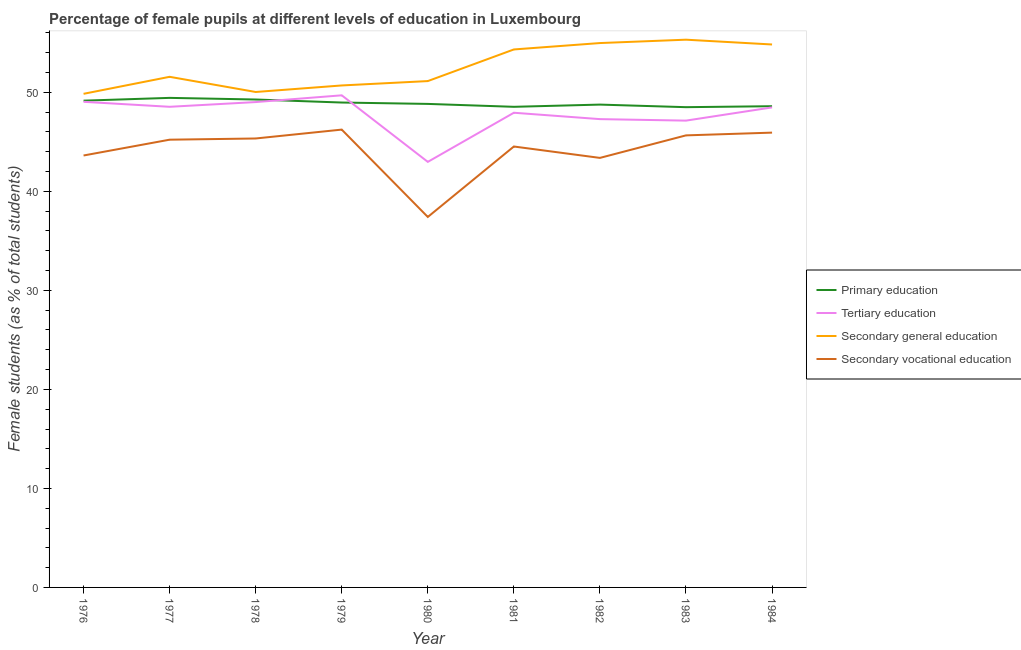Is the number of lines equal to the number of legend labels?
Offer a very short reply. Yes. What is the percentage of female students in tertiary education in 1981?
Offer a very short reply. 47.94. Across all years, what is the maximum percentage of female students in tertiary education?
Ensure brevity in your answer.  49.7. Across all years, what is the minimum percentage of female students in secondary education?
Your answer should be very brief. 49.85. In which year was the percentage of female students in primary education maximum?
Offer a very short reply. 1977. In which year was the percentage of female students in primary education minimum?
Provide a succinct answer. 1983. What is the total percentage of female students in primary education in the graph?
Provide a succinct answer. 440.09. What is the difference between the percentage of female students in tertiary education in 1977 and that in 1983?
Your answer should be very brief. 1.4. What is the difference between the percentage of female students in secondary education in 1978 and the percentage of female students in secondary vocational education in 1979?
Your answer should be compact. 3.8. What is the average percentage of female students in primary education per year?
Make the answer very short. 48.9. In the year 1978, what is the difference between the percentage of female students in tertiary education and percentage of female students in secondary vocational education?
Offer a terse response. 3.68. What is the ratio of the percentage of female students in tertiary education in 1976 to that in 1980?
Make the answer very short. 1.14. What is the difference between the highest and the second highest percentage of female students in tertiary education?
Offer a terse response. 0.66. What is the difference between the highest and the lowest percentage of female students in secondary vocational education?
Your response must be concise. 8.82. In how many years, is the percentage of female students in secondary vocational education greater than the average percentage of female students in secondary vocational education taken over all years?
Provide a short and direct response. 6. Is the sum of the percentage of female students in secondary education in 1980 and 1982 greater than the maximum percentage of female students in tertiary education across all years?
Your response must be concise. Yes. Is it the case that in every year, the sum of the percentage of female students in primary education and percentage of female students in tertiary education is greater than the percentage of female students in secondary education?
Your response must be concise. Yes. Does the percentage of female students in secondary education monotonically increase over the years?
Ensure brevity in your answer.  No. Is the percentage of female students in secondary education strictly greater than the percentage of female students in tertiary education over the years?
Provide a succinct answer. Yes. Is the percentage of female students in secondary education strictly less than the percentage of female students in tertiary education over the years?
Provide a succinct answer. No. How many lines are there?
Ensure brevity in your answer.  4. How many years are there in the graph?
Provide a short and direct response. 9. Are the values on the major ticks of Y-axis written in scientific E-notation?
Ensure brevity in your answer.  No. Where does the legend appear in the graph?
Offer a very short reply. Center right. What is the title of the graph?
Offer a terse response. Percentage of female pupils at different levels of education in Luxembourg. Does "UNAIDS" appear as one of the legend labels in the graph?
Give a very brief answer. No. What is the label or title of the Y-axis?
Keep it short and to the point. Female students (as % of total students). What is the Female students (as % of total students) in Primary education in 1976?
Offer a terse response. 49.16. What is the Female students (as % of total students) of Tertiary education in 1976?
Give a very brief answer. 49.04. What is the Female students (as % of total students) in Secondary general education in 1976?
Your answer should be compact. 49.85. What is the Female students (as % of total students) of Secondary vocational education in 1976?
Give a very brief answer. 43.62. What is the Female students (as % of total students) of Primary education in 1977?
Give a very brief answer. 49.44. What is the Female students (as % of total students) in Tertiary education in 1977?
Your answer should be very brief. 48.54. What is the Female students (as % of total students) in Secondary general education in 1977?
Your response must be concise. 51.57. What is the Female students (as % of total students) of Secondary vocational education in 1977?
Your response must be concise. 45.22. What is the Female students (as % of total students) in Primary education in 1978?
Your response must be concise. 49.28. What is the Female students (as % of total students) in Tertiary education in 1978?
Offer a terse response. 49.02. What is the Female students (as % of total students) in Secondary general education in 1978?
Your response must be concise. 50.04. What is the Female students (as % of total students) of Secondary vocational education in 1978?
Your answer should be very brief. 45.34. What is the Female students (as % of total students) of Primary education in 1979?
Give a very brief answer. 48.97. What is the Female students (as % of total students) of Tertiary education in 1979?
Your response must be concise. 49.7. What is the Female students (as % of total students) in Secondary general education in 1979?
Make the answer very short. 50.7. What is the Female students (as % of total students) of Secondary vocational education in 1979?
Provide a succinct answer. 46.24. What is the Female students (as % of total students) in Primary education in 1980?
Your response must be concise. 48.83. What is the Female students (as % of total students) in Tertiary education in 1980?
Provide a short and direct response. 42.98. What is the Female students (as % of total students) of Secondary general education in 1980?
Offer a very short reply. 51.14. What is the Female students (as % of total students) of Secondary vocational education in 1980?
Offer a very short reply. 37.41. What is the Female students (as % of total students) in Primary education in 1981?
Offer a terse response. 48.54. What is the Female students (as % of total students) in Tertiary education in 1981?
Provide a succinct answer. 47.94. What is the Female students (as % of total students) in Secondary general education in 1981?
Provide a succinct answer. 54.33. What is the Female students (as % of total students) in Secondary vocational education in 1981?
Your answer should be very brief. 44.53. What is the Female students (as % of total students) in Primary education in 1982?
Provide a short and direct response. 48.76. What is the Female students (as % of total students) of Tertiary education in 1982?
Your answer should be very brief. 47.3. What is the Female students (as % of total students) of Secondary general education in 1982?
Make the answer very short. 54.98. What is the Female students (as % of total students) in Secondary vocational education in 1982?
Ensure brevity in your answer.  43.38. What is the Female students (as % of total students) in Primary education in 1983?
Your answer should be very brief. 48.5. What is the Female students (as % of total students) in Tertiary education in 1983?
Keep it short and to the point. 47.14. What is the Female students (as % of total students) of Secondary general education in 1983?
Your response must be concise. 55.32. What is the Female students (as % of total students) of Secondary vocational education in 1983?
Ensure brevity in your answer.  45.65. What is the Female students (as % of total students) in Primary education in 1984?
Offer a very short reply. 48.6. What is the Female students (as % of total students) of Tertiary education in 1984?
Offer a terse response. 48.48. What is the Female students (as % of total students) of Secondary general education in 1984?
Keep it short and to the point. 54.83. What is the Female students (as % of total students) of Secondary vocational education in 1984?
Offer a very short reply. 45.93. Across all years, what is the maximum Female students (as % of total students) in Primary education?
Your answer should be compact. 49.44. Across all years, what is the maximum Female students (as % of total students) in Tertiary education?
Offer a terse response. 49.7. Across all years, what is the maximum Female students (as % of total students) in Secondary general education?
Your answer should be compact. 55.32. Across all years, what is the maximum Female students (as % of total students) in Secondary vocational education?
Make the answer very short. 46.24. Across all years, what is the minimum Female students (as % of total students) of Primary education?
Your response must be concise. 48.5. Across all years, what is the minimum Female students (as % of total students) of Tertiary education?
Keep it short and to the point. 42.98. Across all years, what is the minimum Female students (as % of total students) in Secondary general education?
Keep it short and to the point. 49.85. Across all years, what is the minimum Female students (as % of total students) in Secondary vocational education?
Ensure brevity in your answer.  37.41. What is the total Female students (as % of total students) in Primary education in the graph?
Your response must be concise. 440.09. What is the total Female students (as % of total students) of Tertiary education in the graph?
Ensure brevity in your answer.  430.14. What is the total Female students (as % of total students) of Secondary general education in the graph?
Offer a terse response. 472.75. What is the total Female students (as % of total students) in Secondary vocational education in the graph?
Provide a short and direct response. 397.33. What is the difference between the Female students (as % of total students) in Primary education in 1976 and that in 1977?
Provide a short and direct response. -0.28. What is the difference between the Female students (as % of total students) in Tertiary education in 1976 and that in 1977?
Provide a succinct answer. 0.5. What is the difference between the Female students (as % of total students) of Secondary general education in 1976 and that in 1977?
Provide a short and direct response. -1.72. What is the difference between the Female students (as % of total students) of Secondary vocational education in 1976 and that in 1977?
Provide a short and direct response. -1.6. What is the difference between the Female students (as % of total students) in Primary education in 1976 and that in 1978?
Offer a terse response. -0.12. What is the difference between the Female students (as % of total students) of Tertiary education in 1976 and that in 1978?
Your response must be concise. 0.03. What is the difference between the Female students (as % of total students) in Secondary general education in 1976 and that in 1978?
Make the answer very short. -0.18. What is the difference between the Female students (as % of total students) in Secondary vocational education in 1976 and that in 1978?
Provide a short and direct response. -1.72. What is the difference between the Female students (as % of total students) of Primary education in 1976 and that in 1979?
Keep it short and to the point. 0.19. What is the difference between the Female students (as % of total students) of Tertiary education in 1976 and that in 1979?
Make the answer very short. -0.66. What is the difference between the Female students (as % of total students) in Secondary general education in 1976 and that in 1979?
Make the answer very short. -0.84. What is the difference between the Female students (as % of total students) in Secondary vocational education in 1976 and that in 1979?
Give a very brief answer. -2.61. What is the difference between the Female students (as % of total students) of Primary education in 1976 and that in 1980?
Provide a succinct answer. 0.33. What is the difference between the Female students (as % of total students) in Tertiary education in 1976 and that in 1980?
Keep it short and to the point. 6.07. What is the difference between the Female students (as % of total students) of Secondary general education in 1976 and that in 1980?
Provide a succinct answer. -1.29. What is the difference between the Female students (as % of total students) in Secondary vocational education in 1976 and that in 1980?
Give a very brief answer. 6.21. What is the difference between the Female students (as % of total students) of Primary education in 1976 and that in 1981?
Give a very brief answer. 0.62. What is the difference between the Female students (as % of total students) in Tertiary education in 1976 and that in 1981?
Your answer should be very brief. 1.1. What is the difference between the Female students (as % of total students) in Secondary general education in 1976 and that in 1981?
Offer a very short reply. -4.48. What is the difference between the Female students (as % of total students) in Secondary vocational education in 1976 and that in 1981?
Ensure brevity in your answer.  -0.91. What is the difference between the Female students (as % of total students) of Primary education in 1976 and that in 1982?
Give a very brief answer. 0.4. What is the difference between the Female students (as % of total students) of Tertiary education in 1976 and that in 1982?
Your response must be concise. 1.75. What is the difference between the Female students (as % of total students) of Secondary general education in 1976 and that in 1982?
Your answer should be compact. -5.13. What is the difference between the Female students (as % of total students) of Secondary vocational education in 1976 and that in 1982?
Make the answer very short. 0.24. What is the difference between the Female students (as % of total students) of Primary education in 1976 and that in 1983?
Offer a terse response. 0.66. What is the difference between the Female students (as % of total students) of Tertiary education in 1976 and that in 1983?
Your answer should be compact. 1.9. What is the difference between the Female students (as % of total students) of Secondary general education in 1976 and that in 1983?
Your response must be concise. -5.47. What is the difference between the Female students (as % of total students) in Secondary vocational education in 1976 and that in 1983?
Keep it short and to the point. -2.03. What is the difference between the Female students (as % of total students) of Primary education in 1976 and that in 1984?
Offer a terse response. 0.56. What is the difference between the Female students (as % of total students) of Tertiary education in 1976 and that in 1984?
Ensure brevity in your answer.  0.56. What is the difference between the Female students (as % of total students) of Secondary general education in 1976 and that in 1984?
Your answer should be very brief. -4.98. What is the difference between the Female students (as % of total students) of Secondary vocational education in 1976 and that in 1984?
Provide a succinct answer. -2.31. What is the difference between the Female students (as % of total students) of Primary education in 1977 and that in 1978?
Keep it short and to the point. 0.16. What is the difference between the Female students (as % of total students) in Tertiary education in 1977 and that in 1978?
Your answer should be very brief. -0.48. What is the difference between the Female students (as % of total students) of Secondary general education in 1977 and that in 1978?
Provide a short and direct response. 1.53. What is the difference between the Female students (as % of total students) in Secondary vocational education in 1977 and that in 1978?
Offer a very short reply. -0.12. What is the difference between the Female students (as % of total students) in Primary education in 1977 and that in 1979?
Provide a succinct answer. 0.47. What is the difference between the Female students (as % of total students) of Tertiary education in 1977 and that in 1979?
Make the answer very short. -1.16. What is the difference between the Female students (as % of total students) of Secondary general education in 1977 and that in 1979?
Keep it short and to the point. 0.87. What is the difference between the Female students (as % of total students) in Secondary vocational education in 1977 and that in 1979?
Ensure brevity in your answer.  -1.02. What is the difference between the Female students (as % of total students) of Primary education in 1977 and that in 1980?
Provide a succinct answer. 0.61. What is the difference between the Female students (as % of total students) in Tertiary education in 1977 and that in 1980?
Ensure brevity in your answer.  5.56. What is the difference between the Female students (as % of total students) of Secondary general education in 1977 and that in 1980?
Your response must be concise. 0.43. What is the difference between the Female students (as % of total students) in Secondary vocational education in 1977 and that in 1980?
Your answer should be very brief. 7.8. What is the difference between the Female students (as % of total students) of Primary education in 1977 and that in 1981?
Provide a short and direct response. 0.9. What is the difference between the Female students (as % of total students) in Tertiary education in 1977 and that in 1981?
Offer a very short reply. 0.6. What is the difference between the Female students (as % of total students) in Secondary general education in 1977 and that in 1981?
Provide a succinct answer. -2.76. What is the difference between the Female students (as % of total students) in Secondary vocational education in 1977 and that in 1981?
Your answer should be compact. 0.69. What is the difference between the Female students (as % of total students) of Primary education in 1977 and that in 1982?
Keep it short and to the point. 0.68. What is the difference between the Female students (as % of total students) of Tertiary education in 1977 and that in 1982?
Keep it short and to the point. 1.25. What is the difference between the Female students (as % of total students) of Secondary general education in 1977 and that in 1982?
Your response must be concise. -3.41. What is the difference between the Female students (as % of total students) of Secondary vocational education in 1977 and that in 1982?
Make the answer very short. 1.84. What is the difference between the Female students (as % of total students) of Primary education in 1977 and that in 1983?
Your response must be concise. 0.94. What is the difference between the Female students (as % of total students) in Tertiary education in 1977 and that in 1983?
Make the answer very short. 1.4. What is the difference between the Female students (as % of total students) of Secondary general education in 1977 and that in 1983?
Give a very brief answer. -3.75. What is the difference between the Female students (as % of total students) in Secondary vocational education in 1977 and that in 1983?
Provide a succinct answer. -0.44. What is the difference between the Female students (as % of total students) of Primary education in 1977 and that in 1984?
Provide a short and direct response. 0.84. What is the difference between the Female students (as % of total students) in Tertiary education in 1977 and that in 1984?
Ensure brevity in your answer.  0.06. What is the difference between the Female students (as % of total students) of Secondary general education in 1977 and that in 1984?
Offer a very short reply. -3.27. What is the difference between the Female students (as % of total students) of Secondary vocational education in 1977 and that in 1984?
Make the answer very short. -0.71. What is the difference between the Female students (as % of total students) of Primary education in 1978 and that in 1979?
Offer a very short reply. 0.31. What is the difference between the Female students (as % of total students) in Tertiary education in 1978 and that in 1979?
Your answer should be compact. -0.68. What is the difference between the Female students (as % of total students) in Secondary general education in 1978 and that in 1979?
Give a very brief answer. -0.66. What is the difference between the Female students (as % of total students) of Secondary vocational education in 1978 and that in 1979?
Offer a very short reply. -0.9. What is the difference between the Female students (as % of total students) in Primary education in 1978 and that in 1980?
Keep it short and to the point. 0.45. What is the difference between the Female students (as % of total students) in Tertiary education in 1978 and that in 1980?
Keep it short and to the point. 6.04. What is the difference between the Female students (as % of total students) in Secondary general education in 1978 and that in 1980?
Your response must be concise. -1.1. What is the difference between the Female students (as % of total students) in Secondary vocational education in 1978 and that in 1980?
Your response must be concise. 7.93. What is the difference between the Female students (as % of total students) of Primary education in 1978 and that in 1981?
Provide a succinct answer. 0.74. What is the difference between the Female students (as % of total students) of Tertiary education in 1978 and that in 1981?
Your answer should be very brief. 1.08. What is the difference between the Female students (as % of total students) in Secondary general education in 1978 and that in 1981?
Ensure brevity in your answer.  -4.3. What is the difference between the Female students (as % of total students) of Secondary vocational education in 1978 and that in 1981?
Your response must be concise. 0.81. What is the difference between the Female students (as % of total students) in Primary education in 1978 and that in 1982?
Offer a terse response. 0.52. What is the difference between the Female students (as % of total students) of Tertiary education in 1978 and that in 1982?
Your answer should be compact. 1.72. What is the difference between the Female students (as % of total students) in Secondary general education in 1978 and that in 1982?
Your response must be concise. -4.94. What is the difference between the Female students (as % of total students) of Secondary vocational education in 1978 and that in 1982?
Your answer should be very brief. 1.96. What is the difference between the Female students (as % of total students) of Primary education in 1978 and that in 1983?
Provide a short and direct response. 0.78. What is the difference between the Female students (as % of total students) in Tertiary education in 1978 and that in 1983?
Offer a terse response. 1.87. What is the difference between the Female students (as % of total students) of Secondary general education in 1978 and that in 1983?
Offer a terse response. -5.28. What is the difference between the Female students (as % of total students) in Secondary vocational education in 1978 and that in 1983?
Provide a succinct answer. -0.31. What is the difference between the Female students (as % of total students) in Primary education in 1978 and that in 1984?
Your response must be concise. 0.68. What is the difference between the Female students (as % of total students) in Tertiary education in 1978 and that in 1984?
Make the answer very short. 0.54. What is the difference between the Female students (as % of total students) of Secondary general education in 1978 and that in 1984?
Make the answer very short. -4.8. What is the difference between the Female students (as % of total students) of Secondary vocational education in 1978 and that in 1984?
Give a very brief answer. -0.59. What is the difference between the Female students (as % of total students) of Primary education in 1979 and that in 1980?
Offer a very short reply. 0.14. What is the difference between the Female students (as % of total students) in Tertiary education in 1979 and that in 1980?
Your answer should be very brief. 6.72. What is the difference between the Female students (as % of total students) in Secondary general education in 1979 and that in 1980?
Your answer should be very brief. -0.44. What is the difference between the Female students (as % of total students) of Secondary vocational education in 1979 and that in 1980?
Offer a terse response. 8.82. What is the difference between the Female students (as % of total students) in Primary education in 1979 and that in 1981?
Give a very brief answer. 0.43. What is the difference between the Female students (as % of total students) in Tertiary education in 1979 and that in 1981?
Keep it short and to the point. 1.76. What is the difference between the Female students (as % of total students) of Secondary general education in 1979 and that in 1981?
Offer a terse response. -3.64. What is the difference between the Female students (as % of total students) in Secondary vocational education in 1979 and that in 1981?
Offer a terse response. 1.71. What is the difference between the Female students (as % of total students) of Primary education in 1979 and that in 1982?
Make the answer very short. 0.21. What is the difference between the Female students (as % of total students) in Tertiary education in 1979 and that in 1982?
Offer a terse response. 2.4. What is the difference between the Female students (as % of total students) of Secondary general education in 1979 and that in 1982?
Ensure brevity in your answer.  -4.28. What is the difference between the Female students (as % of total students) in Secondary vocational education in 1979 and that in 1982?
Provide a succinct answer. 2.86. What is the difference between the Female students (as % of total students) in Primary education in 1979 and that in 1983?
Offer a terse response. 0.47. What is the difference between the Female students (as % of total students) of Tertiary education in 1979 and that in 1983?
Give a very brief answer. 2.56. What is the difference between the Female students (as % of total students) of Secondary general education in 1979 and that in 1983?
Ensure brevity in your answer.  -4.62. What is the difference between the Female students (as % of total students) of Secondary vocational education in 1979 and that in 1983?
Make the answer very short. 0.58. What is the difference between the Female students (as % of total students) in Primary education in 1979 and that in 1984?
Give a very brief answer. 0.37. What is the difference between the Female students (as % of total students) of Tertiary education in 1979 and that in 1984?
Keep it short and to the point. 1.22. What is the difference between the Female students (as % of total students) of Secondary general education in 1979 and that in 1984?
Offer a very short reply. -4.14. What is the difference between the Female students (as % of total students) in Secondary vocational education in 1979 and that in 1984?
Give a very brief answer. 0.3. What is the difference between the Female students (as % of total students) of Primary education in 1980 and that in 1981?
Your answer should be compact. 0.29. What is the difference between the Female students (as % of total students) of Tertiary education in 1980 and that in 1981?
Offer a very short reply. -4.96. What is the difference between the Female students (as % of total students) in Secondary general education in 1980 and that in 1981?
Offer a terse response. -3.19. What is the difference between the Female students (as % of total students) in Secondary vocational education in 1980 and that in 1981?
Your answer should be compact. -7.12. What is the difference between the Female students (as % of total students) in Primary education in 1980 and that in 1982?
Provide a succinct answer. 0.07. What is the difference between the Female students (as % of total students) in Tertiary education in 1980 and that in 1982?
Make the answer very short. -4.32. What is the difference between the Female students (as % of total students) in Secondary general education in 1980 and that in 1982?
Make the answer very short. -3.84. What is the difference between the Female students (as % of total students) in Secondary vocational education in 1980 and that in 1982?
Your answer should be very brief. -5.97. What is the difference between the Female students (as % of total students) of Primary education in 1980 and that in 1983?
Ensure brevity in your answer.  0.33. What is the difference between the Female students (as % of total students) of Tertiary education in 1980 and that in 1983?
Give a very brief answer. -4.17. What is the difference between the Female students (as % of total students) of Secondary general education in 1980 and that in 1983?
Your response must be concise. -4.18. What is the difference between the Female students (as % of total students) of Secondary vocational education in 1980 and that in 1983?
Keep it short and to the point. -8.24. What is the difference between the Female students (as % of total students) in Primary education in 1980 and that in 1984?
Your response must be concise. 0.23. What is the difference between the Female students (as % of total students) of Tertiary education in 1980 and that in 1984?
Ensure brevity in your answer.  -5.5. What is the difference between the Female students (as % of total students) of Secondary general education in 1980 and that in 1984?
Give a very brief answer. -3.7. What is the difference between the Female students (as % of total students) of Secondary vocational education in 1980 and that in 1984?
Your answer should be very brief. -8.52. What is the difference between the Female students (as % of total students) in Primary education in 1981 and that in 1982?
Offer a terse response. -0.22. What is the difference between the Female students (as % of total students) of Tertiary education in 1981 and that in 1982?
Provide a short and direct response. 0.64. What is the difference between the Female students (as % of total students) in Secondary general education in 1981 and that in 1982?
Offer a very short reply. -0.65. What is the difference between the Female students (as % of total students) in Secondary vocational education in 1981 and that in 1982?
Make the answer very short. 1.15. What is the difference between the Female students (as % of total students) of Primary education in 1981 and that in 1983?
Give a very brief answer. 0.04. What is the difference between the Female students (as % of total students) in Tertiary education in 1981 and that in 1983?
Your response must be concise. 0.8. What is the difference between the Female students (as % of total students) of Secondary general education in 1981 and that in 1983?
Offer a terse response. -0.99. What is the difference between the Female students (as % of total students) of Secondary vocational education in 1981 and that in 1983?
Ensure brevity in your answer.  -1.12. What is the difference between the Female students (as % of total students) of Primary education in 1981 and that in 1984?
Your answer should be very brief. -0.06. What is the difference between the Female students (as % of total students) in Tertiary education in 1981 and that in 1984?
Keep it short and to the point. -0.54. What is the difference between the Female students (as % of total students) in Secondary general education in 1981 and that in 1984?
Provide a short and direct response. -0.5. What is the difference between the Female students (as % of total students) of Secondary vocational education in 1981 and that in 1984?
Provide a short and direct response. -1.4. What is the difference between the Female students (as % of total students) in Primary education in 1982 and that in 1983?
Keep it short and to the point. 0.26. What is the difference between the Female students (as % of total students) in Tertiary education in 1982 and that in 1983?
Your answer should be compact. 0.15. What is the difference between the Female students (as % of total students) in Secondary general education in 1982 and that in 1983?
Provide a succinct answer. -0.34. What is the difference between the Female students (as % of total students) of Secondary vocational education in 1982 and that in 1983?
Your answer should be compact. -2.27. What is the difference between the Female students (as % of total students) of Primary education in 1982 and that in 1984?
Offer a very short reply. 0.16. What is the difference between the Female students (as % of total students) of Tertiary education in 1982 and that in 1984?
Your answer should be very brief. -1.18. What is the difference between the Female students (as % of total students) of Secondary general education in 1982 and that in 1984?
Your response must be concise. 0.14. What is the difference between the Female students (as % of total students) in Secondary vocational education in 1982 and that in 1984?
Give a very brief answer. -2.55. What is the difference between the Female students (as % of total students) of Primary education in 1983 and that in 1984?
Your answer should be compact. -0.1. What is the difference between the Female students (as % of total students) of Tertiary education in 1983 and that in 1984?
Provide a succinct answer. -1.34. What is the difference between the Female students (as % of total students) of Secondary general education in 1983 and that in 1984?
Your response must be concise. 0.48. What is the difference between the Female students (as % of total students) in Secondary vocational education in 1983 and that in 1984?
Your answer should be very brief. -0.28. What is the difference between the Female students (as % of total students) of Primary education in 1976 and the Female students (as % of total students) of Tertiary education in 1977?
Your answer should be compact. 0.62. What is the difference between the Female students (as % of total students) of Primary education in 1976 and the Female students (as % of total students) of Secondary general education in 1977?
Your answer should be compact. -2.41. What is the difference between the Female students (as % of total students) in Primary education in 1976 and the Female students (as % of total students) in Secondary vocational education in 1977?
Your answer should be very brief. 3.94. What is the difference between the Female students (as % of total students) of Tertiary education in 1976 and the Female students (as % of total students) of Secondary general education in 1977?
Provide a succinct answer. -2.53. What is the difference between the Female students (as % of total students) of Tertiary education in 1976 and the Female students (as % of total students) of Secondary vocational education in 1977?
Provide a succinct answer. 3.83. What is the difference between the Female students (as % of total students) of Secondary general education in 1976 and the Female students (as % of total students) of Secondary vocational education in 1977?
Provide a succinct answer. 4.63. What is the difference between the Female students (as % of total students) in Primary education in 1976 and the Female students (as % of total students) in Tertiary education in 1978?
Make the answer very short. 0.14. What is the difference between the Female students (as % of total students) in Primary education in 1976 and the Female students (as % of total students) in Secondary general education in 1978?
Provide a short and direct response. -0.88. What is the difference between the Female students (as % of total students) of Primary education in 1976 and the Female students (as % of total students) of Secondary vocational education in 1978?
Offer a terse response. 3.82. What is the difference between the Female students (as % of total students) in Tertiary education in 1976 and the Female students (as % of total students) in Secondary general education in 1978?
Your response must be concise. -0.99. What is the difference between the Female students (as % of total students) of Tertiary education in 1976 and the Female students (as % of total students) of Secondary vocational education in 1978?
Ensure brevity in your answer.  3.7. What is the difference between the Female students (as % of total students) of Secondary general education in 1976 and the Female students (as % of total students) of Secondary vocational education in 1978?
Provide a succinct answer. 4.51. What is the difference between the Female students (as % of total students) in Primary education in 1976 and the Female students (as % of total students) in Tertiary education in 1979?
Ensure brevity in your answer.  -0.54. What is the difference between the Female students (as % of total students) of Primary education in 1976 and the Female students (as % of total students) of Secondary general education in 1979?
Provide a short and direct response. -1.53. What is the difference between the Female students (as % of total students) of Primary education in 1976 and the Female students (as % of total students) of Secondary vocational education in 1979?
Offer a terse response. 2.92. What is the difference between the Female students (as % of total students) in Tertiary education in 1976 and the Female students (as % of total students) in Secondary general education in 1979?
Your answer should be compact. -1.65. What is the difference between the Female students (as % of total students) of Tertiary education in 1976 and the Female students (as % of total students) of Secondary vocational education in 1979?
Keep it short and to the point. 2.81. What is the difference between the Female students (as % of total students) in Secondary general education in 1976 and the Female students (as % of total students) in Secondary vocational education in 1979?
Offer a terse response. 3.62. What is the difference between the Female students (as % of total students) in Primary education in 1976 and the Female students (as % of total students) in Tertiary education in 1980?
Offer a terse response. 6.18. What is the difference between the Female students (as % of total students) in Primary education in 1976 and the Female students (as % of total students) in Secondary general education in 1980?
Keep it short and to the point. -1.98. What is the difference between the Female students (as % of total students) of Primary education in 1976 and the Female students (as % of total students) of Secondary vocational education in 1980?
Provide a short and direct response. 11.75. What is the difference between the Female students (as % of total students) in Tertiary education in 1976 and the Female students (as % of total students) in Secondary general education in 1980?
Offer a very short reply. -2.09. What is the difference between the Female students (as % of total students) of Tertiary education in 1976 and the Female students (as % of total students) of Secondary vocational education in 1980?
Give a very brief answer. 11.63. What is the difference between the Female students (as % of total students) in Secondary general education in 1976 and the Female students (as % of total students) in Secondary vocational education in 1980?
Make the answer very short. 12.44. What is the difference between the Female students (as % of total students) of Primary education in 1976 and the Female students (as % of total students) of Tertiary education in 1981?
Provide a short and direct response. 1.22. What is the difference between the Female students (as % of total students) of Primary education in 1976 and the Female students (as % of total students) of Secondary general education in 1981?
Make the answer very short. -5.17. What is the difference between the Female students (as % of total students) in Primary education in 1976 and the Female students (as % of total students) in Secondary vocational education in 1981?
Ensure brevity in your answer.  4.63. What is the difference between the Female students (as % of total students) of Tertiary education in 1976 and the Female students (as % of total students) of Secondary general education in 1981?
Offer a terse response. -5.29. What is the difference between the Female students (as % of total students) of Tertiary education in 1976 and the Female students (as % of total students) of Secondary vocational education in 1981?
Provide a succinct answer. 4.51. What is the difference between the Female students (as % of total students) in Secondary general education in 1976 and the Female students (as % of total students) in Secondary vocational education in 1981?
Provide a succinct answer. 5.32. What is the difference between the Female students (as % of total students) in Primary education in 1976 and the Female students (as % of total students) in Tertiary education in 1982?
Your answer should be very brief. 1.87. What is the difference between the Female students (as % of total students) in Primary education in 1976 and the Female students (as % of total students) in Secondary general education in 1982?
Your response must be concise. -5.82. What is the difference between the Female students (as % of total students) in Primary education in 1976 and the Female students (as % of total students) in Secondary vocational education in 1982?
Give a very brief answer. 5.78. What is the difference between the Female students (as % of total students) of Tertiary education in 1976 and the Female students (as % of total students) of Secondary general education in 1982?
Keep it short and to the point. -5.93. What is the difference between the Female students (as % of total students) of Tertiary education in 1976 and the Female students (as % of total students) of Secondary vocational education in 1982?
Your response must be concise. 5.66. What is the difference between the Female students (as % of total students) of Secondary general education in 1976 and the Female students (as % of total students) of Secondary vocational education in 1982?
Keep it short and to the point. 6.47. What is the difference between the Female students (as % of total students) in Primary education in 1976 and the Female students (as % of total students) in Tertiary education in 1983?
Offer a terse response. 2.02. What is the difference between the Female students (as % of total students) of Primary education in 1976 and the Female students (as % of total students) of Secondary general education in 1983?
Provide a succinct answer. -6.16. What is the difference between the Female students (as % of total students) of Primary education in 1976 and the Female students (as % of total students) of Secondary vocational education in 1983?
Ensure brevity in your answer.  3.51. What is the difference between the Female students (as % of total students) of Tertiary education in 1976 and the Female students (as % of total students) of Secondary general education in 1983?
Your response must be concise. -6.27. What is the difference between the Female students (as % of total students) of Tertiary education in 1976 and the Female students (as % of total students) of Secondary vocational education in 1983?
Ensure brevity in your answer.  3.39. What is the difference between the Female students (as % of total students) of Secondary general education in 1976 and the Female students (as % of total students) of Secondary vocational education in 1983?
Your response must be concise. 4.2. What is the difference between the Female students (as % of total students) of Primary education in 1976 and the Female students (as % of total students) of Tertiary education in 1984?
Offer a terse response. 0.68. What is the difference between the Female students (as % of total students) in Primary education in 1976 and the Female students (as % of total students) in Secondary general education in 1984?
Your answer should be very brief. -5.67. What is the difference between the Female students (as % of total students) of Primary education in 1976 and the Female students (as % of total students) of Secondary vocational education in 1984?
Offer a terse response. 3.23. What is the difference between the Female students (as % of total students) in Tertiary education in 1976 and the Female students (as % of total students) in Secondary general education in 1984?
Offer a very short reply. -5.79. What is the difference between the Female students (as % of total students) of Tertiary education in 1976 and the Female students (as % of total students) of Secondary vocational education in 1984?
Provide a succinct answer. 3.11. What is the difference between the Female students (as % of total students) in Secondary general education in 1976 and the Female students (as % of total students) in Secondary vocational education in 1984?
Provide a succinct answer. 3.92. What is the difference between the Female students (as % of total students) of Primary education in 1977 and the Female students (as % of total students) of Tertiary education in 1978?
Keep it short and to the point. 0.42. What is the difference between the Female students (as % of total students) of Primary education in 1977 and the Female students (as % of total students) of Secondary general education in 1978?
Ensure brevity in your answer.  -0.59. What is the difference between the Female students (as % of total students) of Primary education in 1977 and the Female students (as % of total students) of Secondary vocational education in 1978?
Provide a succinct answer. 4.1. What is the difference between the Female students (as % of total students) in Tertiary education in 1977 and the Female students (as % of total students) in Secondary general education in 1978?
Provide a short and direct response. -1.5. What is the difference between the Female students (as % of total students) in Tertiary education in 1977 and the Female students (as % of total students) in Secondary vocational education in 1978?
Your answer should be very brief. 3.2. What is the difference between the Female students (as % of total students) in Secondary general education in 1977 and the Female students (as % of total students) in Secondary vocational education in 1978?
Give a very brief answer. 6.23. What is the difference between the Female students (as % of total students) of Primary education in 1977 and the Female students (as % of total students) of Tertiary education in 1979?
Your answer should be compact. -0.26. What is the difference between the Female students (as % of total students) in Primary education in 1977 and the Female students (as % of total students) in Secondary general education in 1979?
Offer a terse response. -1.25. What is the difference between the Female students (as % of total students) of Primary education in 1977 and the Female students (as % of total students) of Secondary vocational education in 1979?
Your answer should be very brief. 3.21. What is the difference between the Female students (as % of total students) of Tertiary education in 1977 and the Female students (as % of total students) of Secondary general education in 1979?
Keep it short and to the point. -2.15. What is the difference between the Female students (as % of total students) in Tertiary education in 1977 and the Female students (as % of total students) in Secondary vocational education in 1979?
Make the answer very short. 2.3. What is the difference between the Female students (as % of total students) in Secondary general education in 1977 and the Female students (as % of total students) in Secondary vocational education in 1979?
Provide a succinct answer. 5.33. What is the difference between the Female students (as % of total students) in Primary education in 1977 and the Female students (as % of total students) in Tertiary education in 1980?
Offer a very short reply. 6.47. What is the difference between the Female students (as % of total students) in Primary education in 1977 and the Female students (as % of total students) in Secondary general education in 1980?
Provide a short and direct response. -1.7. What is the difference between the Female students (as % of total students) of Primary education in 1977 and the Female students (as % of total students) of Secondary vocational education in 1980?
Your answer should be compact. 12.03. What is the difference between the Female students (as % of total students) of Tertiary education in 1977 and the Female students (as % of total students) of Secondary general education in 1980?
Ensure brevity in your answer.  -2.6. What is the difference between the Female students (as % of total students) in Tertiary education in 1977 and the Female students (as % of total students) in Secondary vocational education in 1980?
Offer a very short reply. 11.13. What is the difference between the Female students (as % of total students) of Secondary general education in 1977 and the Female students (as % of total students) of Secondary vocational education in 1980?
Give a very brief answer. 14.15. What is the difference between the Female students (as % of total students) of Primary education in 1977 and the Female students (as % of total students) of Tertiary education in 1981?
Provide a short and direct response. 1.5. What is the difference between the Female students (as % of total students) in Primary education in 1977 and the Female students (as % of total students) in Secondary general education in 1981?
Make the answer very short. -4.89. What is the difference between the Female students (as % of total students) in Primary education in 1977 and the Female students (as % of total students) in Secondary vocational education in 1981?
Ensure brevity in your answer.  4.91. What is the difference between the Female students (as % of total students) of Tertiary education in 1977 and the Female students (as % of total students) of Secondary general education in 1981?
Your response must be concise. -5.79. What is the difference between the Female students (as % of total students) of Tertiary education in 1977 and the Female students (as % of total students) of Secondary vocational education in 1981?
Your answer should be compact. 4.01. What is the difference between the Female students (as % of total students) of Secondary general education in 1977 and the Female students (as % of total students) of Secondary vocational education in 1981?
Your answer should be very brief. 7.04. What is the difference between the Female students (as % of total students) of Primary education in 1977 and the Female students (as % of total students) of Tertiary education in 1982?
Provide a succinct answer. 2.15. What is the difference between the Female students (as % of total students) in Primary education in 1977 and the Female students (as % of total students) in Secondary general education in 1982?
Your answer should be very brief. -5.54. What is the difference between the Female students (as % of total students) of Primary education in 1977 and the Female students (as % of total students) of Secondary vocational education in 1982?
Provide a succinct answer. 6.06. What is the difference between the Female students (as % of total students) in Tertiary education in 1977 and the Female students (as % of total students) in Secondary general education in 1982?
Provide a short and direct response. -6.44. What is the difference between the Female students (as % of total students) of Tertiary education in 1977 and the Female students (as % of total students) of Secondary vocational education in 1982?
Make the answer very short. 5.16. What is the difference between the Female students (as % of total students) in Secondary general education in 1977 and the Female students (as % of total students) in Secondary vocational education in 1982?
Provide a succinct answer. 8.19. What is the difference between the Female students (as % of total students) in Primary education in 1977 and the Female students (as % of total students) in Tertiary education in 1983?
Make the answer very short. 2.3. What is the difference between the Female students (as % of total students) in Primary education in 1977 and the Female students (as % of total students) in Secondary general education in 1983?
Keep it short and to the point. -5.88. What is the difference between the Female students (as % of total students) in Primary education in 1977 and the Female students (as % of total students) in Secondary vocational education in 1983?
Provide a succinct answer. 3.79. What is the difference between the Female students (as % of total students) of Tertiary education in 1977 and the Female students (as % of total students) of Secondary general education in 1983?
Give a very brief answer. -6.78. What is the difference between the Female students (as % of total students) of Tertiary education in 1977 and the Female students (as % of total students) of Secondary vocational education in 1983?
Keep it short and to the point. 2.89. What is the difference between the Female students (as % of total students) in Secondary general education in 1977 and the Female students (as % of total students) in Secondary vocational education in 1983?
Make the answer very short. 5.91. What is the difference between the Female students (as % of total students) of Primary education in 1977 and the Female students (as % of total students) of Tertiary education in 1984?
Provide a succinct answer. 0.96. What is the difference between the Female students (as % of total students) in Primary education in 1977 and the Female students (as % of total students) in Secondary general education in 1984?
Your response must be concise. -5.39. What is the difference between the Female students (as % of total students) in Primary education in 1977 and the Female students (as % of total students) in Secondary vocational education in 1984?
Provide a short and direct response. 3.51. What is the difference between the Female students (as % of total students) of Tertiary education in 1977 and the Female students (as % of total students) of Secondary general education in 1984?
Ensure brevity in your answer.  -6.29. What is the difference between the Female students (as % of total students) of Tertiary education in 1977 and the Female students (as % of total students) of Secondary vocational education in 1984?
Your answer should be compact. 2.61. What is the difference between the Female students (as % of total students) in Secondary general education in 1977 and the Female students (as % of total students) in Secondary vocational education in 1984?
Make the answer very short. 5.64. What is the difference between the Female students (as % of total students) of Primary education in 1978 and the Female students (as % of total students) of Tertiary education in 1979?
Provide a short and direct response. -0.42. What is the difference between the Female students (as % of total students) in Primary education in 1978 and the Female students (as % of total students) in Secondary general education in 1979?
Your answer should be very brief. -1.42. What is the difference between the Female students (as % of total students) of Primary education in 1978 and the Female students (as % of total students) of Secondary vocational education in 1979?
Provide a short and direct response. 3.04. What is the difference between the Female students (as % of total students) in Tertiary education in 1978 and the Female students (as % of total students) in Secondary general education in 1979?
Give a very brief answer. -1.68. What is the difference between the Female students (as % of total students) of Tertiary education in 1978 and the Female students (as % of total students) of Secondary vocational education in 1979?
Your answer should be compact. 2.78. What is the difference between the Female students (as % of total students) of Secondary general education in 1978 and the Female students (as % of total students) of Secondary vocational education in 1979?
Your answer should be compact. 3.8. What is the difference between the Female students (as % of total students) in Primary education in 1978 and the Female students (as % of total students) in Tertiary education in 1980?
Your response must be concise. 6.3. What is the difference between the Female students (as % of total students) of Primary education in 1978 and the Female students (as % of total students) of Secondary general education in 1980?
Your response must be concise. -1.86. What is the difference between the Female students (as % of total students) in Primary education in 1978 and the Female students (as % of total students) in Secondary vocational education in 1980?
Make the answer very short. 11.86. What is the difference between the Female students (as % of total students) in Tertiary education in 1978 and the Female students (as % of total students) in Secondary general education in 1980?
Make the answer very short. -2.12. What is the difference between the Female students (as % of total students) of Tertiary education in 1978 and the Female students (as % of total students) of Secondary vocational education in 1980?
Provide a short and direct response. 11.6. What is the difference between the Female students (as % of total students) in Secondary general education in 1978 and the Female students (as % of total students) in Secondary vocational education in 1980?
Make the answer very short. 12.62. What is the difference between the Female students (as % of total students) in Primary education in 1978 and the Female students (as % of total students) in Tertiary education in 1981?
Offer a terse response. 1.34. What is the difference between the Female students (as % of total students) in Primary education in 1978 and the Female students (as % of total students) in Secondary general education in 1981?
Offer a very short reply. -5.05. What is the difference between the Female students (as % of total students) in Primary education in 1978 and the Female students (as % of total students) in Secondary vocational education in 1981?
Give a very brief answer. 4.75. What is the difference between the Female students (as % of total students) in Tertiary education in 1978 and the Female students (as % of total students) in Secondary general education in 1981?
Offer a very short reply. -5.31. What is the difference between the Female students (as % of total students) in Tertiary education in 1978 and the Female students (as % of total students) in Secondary vocational education in 1981?
Your response must be concise. 4.49. What is the difference between the Female students (as % of total students) of Secondary general education in 1978 and the Female students (as % of total students) of Secondary vocational education in 1981?
Make the answer very short. 5.51. What is the difference between the Female students (as % of total students) of Primary education in 1978 and the Female students (as % of total students) of Tertiary education in 1982?
Provide a succinct answer. 1.98. What is the difference between the Female students (as % of total students) of Primary education in 1978 and the Female students (as % of total students) of Secondary general education in 1982?
Your answer should be compact. -5.7. What is the difference between the Female students (as % of total students) in Primary education in 1978 and the Female students (as % of total students) in Secondary vocational education in 1982?
Offer a terse response. 5.9. What is the difference between the Female students (as % of total students) of Tertiary education in 1978 and the Female students (as % of total students) of Secondary general education in 1982?
Ensure brevity in your answer.  -5.96. What is the difference between the Female students (as % of total students) of Tertiary education in 1978 and the Female students (as % of total students) of Secondary vocational education in 1982?
Offer a terse response. 5.64. What is the difference between the Female students (as % of total students) in Secondary general education in 1978 and the Female students (as % of total students) in Secondary vocational education in 1982?
Your response must be concise. 6.66. What is the difference between the Female students (as % of total students) in Primary education in 1978 and the Female students (as % of total students) in Tertiary education in 1983?
Ensure brevity in your answer.  2.13. What is the difference between the Female students (as % of total students) of Primary education in 1978 and the Female students (as % of total students) of Secondary general education in 1983?
Offer a terse response. -6.04. What is the difference between the Female students (as % of total students) in Primary education in 1978 and the Female students (as % of total students) in Secondary vocational education in 1983?
Keep it short and to the point. 3.62. What is the difference between the Female students (as % of total students) of Tertiary education in 1978 and the Female students (as % of total students) of Secondary general education in 1983?
Make the answer very short. -6.3. What is the difference between the Female students (as % of total students) in Tertiary education in 1978 and the Female students (as % of total students) in Secondary vocational education in 1983?
Provide a short and direct response. 3.36. What is the difference between the Female students (as % of total students) in Secondary general education in 1978 and the Female students (as % of total students) in Secondary vocational education in 1983?
Keep it short and to the point. 4.38. What is the difference between the Female students (as % of total students) of Primary education in 1978 and the Female students (as % of total students) of Tertiary education in 1984?
Offer a terse response. 0.8. What is the difference between the Female students (as % of total students) of Primary education in 1978 and the Female students (as % of total students) of Secondary general education in 1984?
Make the answer very short. -5.56. What is the difference between the Female students (as % of total students) in Primary education in 1978 and the Female students (as % of total students) in Secondary vocational education in 1984?
Your response must be concise. 3.35. What is the difference between the Female students (as % of total students) in Tertiary education in 1978 and the Female students (as % of total students) in Secondary general education in 1984?
Your answer should be compact. -5.82. What is the difference between the Female students (as % of total students) of Tertiary education in 1978 and the Female students (as % of total students) of Secondary vocational education in 1984?
Provide a short and direct response. 3.09. What is the difference between the Female students (as % of total students) of Secondary general education in 1978 and the Female students (as % of total students) of Secondary vocational education in 1984?
Give a very brief answer. 4.1. What is the difference between the Female students (as % of total students) in Primary education in 1979 and the Female students (as % of total students) in Tertiary education in 1980?
Make the answer very short. 5.99. What is the difference between the Female students (as % of total students) of Primary education in 1979 and the Female students (as % of total students) of Secondary general education in 1980?
Give a very brief answer. -2.17. What is the difference between the Female students (as % of total students) of Primary education in 1979 and the Female students (as % of total students) of Secondary vocational education in 1980?
Offer a terse response. 11.56. What is the difference between the Female students (as % of total students) of Tertiary education in 1979 and the Female students (as % of total students) of Secondary general education in 1980?
Make the answer very short. -1.44. What is the difference between the Female students (as % of total students) in Tertiary education in 1979 and the Female students (as % of total students) in Secondary vocational education in 1980?
Your answer should be compact. 12.29. What is the difference between the Female students (as % of total students) in Secondary general education in 1979 and the Female students (as % of total students) in Secondary vocational education in 1980?
Make the answer very short. 13.28. What is the difference between the Female students (as % of total students) in Primary education in 1979 and the Female students (as % of total students) in Tertiary education in 1981?
Make the answer very short. 1.03. What is the difference between the Female students (as % of total students) in Primary education in 1979 and the Female students (as % of total students) in Secondary general education in 1981?
Provide a short and direct response. -5.36. What is the difference between the Female students (as % of total students) of Primary education in 1979 and the Female students (as % of total students) of Secondary vocational education in 1981?
Your answer should be very brief. 4.44. What is the difference between the Female students (as % of total students) of Tertiary education in 1979 and the Female students (as % of total students) of Secondary general education in 1981?
Provide a succinct answer. -4.63. What is the difference between the Female students (as % of total students) in Tertiary education in 1979 and the Female students (as % of total students) in Secondary vocational education in 1981?
Make the answer very short. 5.17. What is the difference between the Female students (as % of total students) of Secondary general education in 1979 and the Female students (as % of total students) of Secondary vocational education in 1981?
Your response must be concise. 6.17. What is the difference between the Female students (as % of total students) in Primary education in 1979 and the Female students (as % of total students) in Tertiary education in 1982?
Make the answer very short. 1.68. What is the difference between the Female students (as % of total students) of Primary education in 1979 and the Female students (as % of total students) of Secondary general education in 1982?
Provide a short and direct response. -6.01. What is the difference between the Female students (as % of total students) of Primary education in 1979 and the Female students (as % of total students) of Secondary vocational education in 1982?
Your answer should be very brief. 5.59. What is the difference between the Female students (as % of total students) of Tertiary education in 1979 and the Female students (as % of total students) of Secondary general education in 1982?
Offer a very short reply. -5.28. What is the difference between the Female students (as % of total students) of Tertiary education in 1979 and the Female students (as % of total students) of Secondary vocational education in 1982?
Your answer should be compact. 6.32. What is the difference between the Female students (as % of total students) of Secondary general education in 1979 and the Female students (as % of total students) of Secondary vocational education in 1982?
Your response must be concise. 7.32. What is the difference between the Female students (as % of total students) of Primary education in 1979 and the Female students (as % of total students) of Tertiary education in 1983?
Make the answer very short. 1.83. What is the difference between the Female students (as % of total students) of Primary education in 1979 and the Female students (as % of total students) of Secondary general education in 1983?
Ensure brevity in your answer.  -6.35. What is the difference between the Female students (as % of total students) of Primary education in 1979 and the Female students (as % of total students) of Secondary vocational education in 1983?
Provide a short and direct response. 3.32. What is the difference between the Female students (as % of total students) in Tertiary education in 1979 and the Female students (as % of total students) in Secondary general education in 1983?
Offer a very short reply. -5.62. What is the difference between the Female students (as % of total students) of Tertiary education in 1979 and the Female students (as % of total students) of Secondary vocational education in 1983?
Offer a very short reply. 4.05. What is the difference between the Female students (as % of total students) in Secondary general education in 1979 and the Female students (as % of total students) in Secondary vocational education in 1983?
Make the answer very short. 5.04. What is the difference between the Female students (as % of total students) of Primary education in 1979 and the Female students (as % of total students) of Tertiary education in 1984?
Your response must be concise. 0.49. What is the difference between the Female students (as % of total students) in Primary education in 1979 and the Female students (as % of total students) in Secondary general education in 1984?
Provide a succinct answer. -5.86. What is the difference between the Female students (as % of total students) in Primary education in 1979 and the Female students (as % of total students) in Secondary vocational education in 1984?
Give a very brief answer. 3.04. What is the difference between the Female students (as % of total students) of Tertiary education in 1979 and the Female students (as % of total students) of Secondary general education in 1984?
Ensure brevity in your answer.  -5.13. What is the difference between the Female students (as % of total students) in Tertiary education in 1979 and the Female students (as % of total students) in Secondary vocational education in 1984?
Make the answer very short. 3.77. What is the difference between the Female students (as % of total students) of Secondary general education in 1979 and the Female students (as % of total students) of Secondary vocational education in 1984?
Offer a very short reply. 4.76. What is the difference between the Female students (as % of total students) in Primary education in 1980 and the Female students (as % of total students) in Tertiary education in 1981?
Provide a short and direct response. 0.89. What is the difference between the Female students (as % of total students) of Primary education in 1980 and the Female students (as % of total students) of Secondary vocational education in 1981?
Your answer should be compact. 4.3. What is the difference between the Female students (as % of total students) of Tertiary education in 1980 and the Female students (as % of total students) of Secondary general education in 1981?
Provide a succinct answer. -11.36. What is the difference between the Female students (as % of total students) of Tertiary education in 1980 and the Female students (as % of total students) of Secondary vocational education in 1981?
Provide a succinct answer. -1.55. What is the difference between the Female students (as % of total students) of Secondary general education in 1980 and the Female students (as % of total students) of Secondary vocational education in 1981?
Make the answer very short. 6.61. What is the difference between the Female students (as % of total students) in Primary education in 1980 and the Female students (as % of total students) in Tertiary education in 1982?
Offer a very short reply. 1.54. What is the difference between the Female students (as % of total students) of Primary education in 1980 and the Female students (as % of total students) of Secondary general education in 1982?
Give a very brief answer. -6.15. What is the difference between the Female students (as % of total students) in Primary education in 1980 and the Female students (as % of total students) in Secondary vocational education in 1982?
Provide a short and direct response. 5.45. What is the difference between the Female students (as % of total students) of Tertiary education in 1980 and the Female students (as % of total students) of Secondary general education in 1982?
Keep it short and to the point. -12. What is the difference between the Female students (as % of total students) in Tertiary education in 1980 and the Female students (as % of total students) in Secondary vocational education in 1982?
Give a very brief answer. -0.4. What is the difference between the Female students (as % of total students) in Secondary general education in 1980 and the Female students (as % of total students) in Secondary vocational education in 1982?
Offer a very short reply. 7.76. What is the difference between the Female students (as % of total students) of Primary education in 1980 and the Female students (as % of total students) of Tertiary education in 1983?
Your answer should be compact. 1.69. What is the difference between the Female students (as % of total students) in Primary education in 1980 and the Female students (as % of total students) in Secondary general education in 1983?
Your response must be concise. -6.49. What is the difference between the Female students (as % of total students) in Primary education in 1980 and the Female students (as % of total students) in Secondary vocational education in 1983?
Give a very brief answer. 3.18. What is the difference between the Female students (as % of total students) in Tertiary education in 1980 and the Female students (as % of total students) in Secondary general education in 1983?
Offer a very short reply. -12.34. What is the difference between the Female students (as % of total students) in Tertiary education in 1980 and the Female students (as % of total students) in Secondary vocational education in 1983?
Provide a succinct answer. -2.68. What is the difference between the Female students (as % of total students) in Secondary general education in 1980 and the Female students (as % of total students) in Secondary vocational education in 1983?
Offer a terse response. 5.48. What is the difference between the Female students (as % of total students) of Primary education in 1980 and the Female students (as % of total students) of Tertiary education in 1984?
Your response must be concise. 0.35. What is the difference between the Female students (as % of total students) of Primary education in 1980 and the Female students (as % of total students) of Secondary general education in 1984?
Give a very brief answer. -6. What is the difference between the Female students (as % of total students) in Primary education in 1980 and the Female students (as % of total students) in Secondary vocational education in 1984?
Your answer should be compact. 2.9. What is the difference between the Female students (as % of total students) of Tertiary education in 1980 and the Female students (as % of total students) of Secondary general education in 1984?
Make the answer very short. -11.86. What is the difference between the Female students (as % of total students) in Tertiary education in 1980 and the Female students (as % of total students) in Secondary vocational education in 1984?
Provide a succinct answer. -2.96. What is the difference between the Female students (as % of total students) of Secondary general education in 1980 and the Female students (as % of total students) of Secondary vocational education in 1984?
Provide a succinct answer. 5.21. What is the difference between the Female students (as % of total students) in Primary education in 1981 and the Female students (as % of total students) in Tertiary education in 1982?
Ensure brevity in your answer.  1.24. What is the difference between the Female students (as % of total students) of Primary education in 1981 and the Female students (as % of total students) of Secondary general education in 1982?
Offer a terse response. -6.44. What is the difference between the Female students (as % of total students) in Primary education in 1981 and the Female students (as % of total students) in Secondary vocational education in 1982?
Make the answer very short. 5.16. What is the difference between the Female students (as % of total students) of Tertiary education in 1981 and the Female students (as % of total students) of Secondary general education in 1982?
Your response must be concise. -7.04. What is the difference between the Female students (as % of total students) of Tertiary education in 1981 and the Female students (as % of total students) of Secondary vocational education in 1982?
Your answer should be compact. 4.56. What is the difference between the Female students (as % of total students) of Secondary general education in 1981 and the Female students (as % of total students) of Secondary vocational education in 1982?
Make the answer very short. 10.95. What is the difference between the Female students (as % of total students) in Primary education in 1981 and the Female students (as % of total students) in Tertiary education in 1983?
Provide a short and direct response. 1.39. What is the difference between the Female students (as % of total students) of Primary education in 1981 and the Female students (as % of total students) of Secondary general education in 1983?
Offer a terse response. -6.78. What is the difference between the Female students (as % of total students) in Primary education in 1981 and the Female students (as % of total students) in Secondary vocational education in 1983?
Your answer should be very brief. 2.88. What is the difference between the Female students (as % of total students) in Tertiary education in 1981 and the Female students (as % of total students) in Secondary general education in 1983?
Keep it short and to the point. -7.38. What is the difference between the Female students (as % of total students) in Tertiary education in 1981 and the Female students (as % of total students) in Secondary vocational education in 1983?
Offer a very short reply. 2.29. What is the difference between the Female students (as % of total students) of Secondary general education in 1981 and the Female students (as % of total students) of Secondary vocational education in 1983?
Provide a succinct answer. 8.68. What is the difference between the Female students (as % of total students) of Primary education in 1981 and the Female students (as % of total students) of Tertiary education in 1984?
Provide a succinct answer. 0.06. What is the difference between the Female students (as % of total students) in Primary education in 1981 and the Female students (as % of total students) in Secondary general education in 1984?
Your answer should be very brief. -6.3. What is the difference between the Female students (as % of total students) of Primary education in 1981 and the Female students (as % of total students) of Secondary vocational education in 1984?
Your response must be concise. 2.61. What is the difference between the Female students (as % of total students) of Tertiary education in 1981 and the Female students (as % of total students) of Secondary general education in 1984?
Your response must be concise. -6.89. What is the difference between the Female students (as % of total students) in Tertiary education in 1981 and the Female students (as % of total students) in Secondary vocational education in 1984?
Ensure brevity in your answer.  2.01. What is the difference between the Female students (as % of total students) in Secondary general education in 1981 and the Female students (as % of total students) in Secondary vocational education in 1984?
Make the answer very short. 8.4. What is the difference between the Female students (as % of total students) in Primary education in 1982 and the Female students (as % of total students) in Tertiary education in 1983?
Your answer should be very brief. 1.62. What is the difference between the Female students (as % of total students) of Primary education in 1982 and the Female students (as % of total students) of Secondary general education in 1983?
Provide a succinct answer. -6.56. What is the difference between the Female students (as % of total students) in Primary education in 1982 and the Female students (as % of total students) in Secondary vocational education in 1983?
Your response must be concise. 3.11. What is the difference between the Female students (as % of total students) of Tertiary education in 1982 and the Female students (as % of total students) of Secondary general education in 1983?
Provide a short and direct response. -8.02. What is the difference between the Female students (as % of total students) of Tertiary education in 1982 and the Female students (as % of total students) of Secondary vocational education in 1983?
Ensure brevity in your answer.  1.64. What is the difference between the Female students (as % of total students) of Secondary general education in 1982 and the Female students (as % of total students) of Secondary vocational education in 1983?
Provide a short and direct response. 9.32. What is the difference between the Female students (as % of total students) of Primary education in 1982 and the Female students (as % of total students) of Tertiary education in 1984?
Provide a short and direct response. 0.28. What is the difference between the Female students (as % of total students) in Primary education in 1982 and the Female students (as % of total students) in Secondary general education in 1984?
Give a very brief answer. -6.07. What is the difference between the Female students (as % of total students) of Primary education in 1982 and the Female students (as % of total students) of Secondary vocational education in 1984?
Keep it short and to the point. 2.83. What is the difference between the Female students (as % of total students) in Tertiary education in 1982 and the Female students (as % of total students) in Secondary general education in 1984?
Make the answer very short. -7.54. What is the difference between the Female students (as % of total students) of Tertiary education in 1982 and the Female students (as % of total students) of Secondary vocational education in 1984?
Ensure brevity in your answer.  1.36. What is the difference between the Female students (as % of total students) in Secondary general education in 1982 and the Female students (as % of total students) in Secondary vocational education in 1984?
Ensure brevity in your answer.  9.05. What is the difference between the Female students (as % of total students) of Primary education in 1983 and the Female students (as % of total students) of Tertiary education in 1984?
Provide a short and direct response. 0.02. What is the difference between the Female students (as % of total students) of Primary education in 1983 and the Female students (as % of total students) of Secondary general education in 1984?
Your answer should be compact. -6.33. What is the difference between the Female students (as % of total students) in Primary education in 1983 and the Female students (as % of total students) in Secondary vocational education in 1984?
Provide a succinct answer. 2.57. What is the difference between the Female students (as % of total students) in Tertiary education in 1983 and the Female students (as % of total students) in Secondary general education in 1984?
Your answer should be compact. -7.69. What is the difference between the Female students (as % of total students) in Tertiary education in 1983 and the Female students (as % of total students) in Secondary vocational education in 1984?
Offer a terse response. 1.21. What is the difference between the Female students (as % of total students) of Secondary general education in 1983 and the Female students (as % of total students) of Secondary vocational education in 1984?
Provide a short and direct response. 9.39. What is the average Female students (as % of total students) in Primary education per year?
Give a very brief answer. 48.9. What is the average Female students (as % of total students) in Tertiary education per year?
Your response must be concise. 47.79. What is the average Female students (as % of total students) of Secondary general education per year?
Ensure brevity in your answer.  52.53. What is the average Female students (as % of total students) of Secondary vocational education per year?
Offer a very short reply. 44.15. In the year 1976, what is the difference between the Female students (as % of total students) of Primary education and Female students (as % of total students) of Tertiary education?
Ensure brevity in your answer.  0.12. In the year 1976, what is the difference between the Female students (as % of total students) of Primary education and Female students (as % of total students) of Secondary general education?
Ensure brevity in your answer.  -0.69. In the year 1976, what is the difference between the Female students (as % of total students) in Primary education and Female students (as % of total students) in Secondary vocational education?
Your response must be concise. 5.54. In the year 1976, what is the difference between the Female students (as % of total students) of Tertiary education and Female students (as % of total students) of Secondary general education?
Make the answer very short. -0.81. In the year 1976, what is the difference between the Female students (as % of total students) of Tertiary education and Female students (as % of total students) of Secondary vocational education?
Your response must be concise. 5.42. In the year 1976, what is the difference between the Female students (as % of total students) of Secondary general education and Female students (as % of total students) of Secondary vocational education?
Your answer should be compact. 6.23. In the year 1977, what is the difference between the Female students (as % of total students) in Primary education and Female students (as % of total students) in Tertiary education?
Your answer should be compact. 0.9. In the year 1977, what is the difference between the Female students (as % of total students) of Primary education and Female students (as % of total students) of Secondary general education?
Ensure brevity in your answer.  -2.13. In the year 1977, what is the difference between the Female students (as % of total students) in Primary education and Female students (as % of total students) in Secondary vocational education?
Provide a short and direct response. 4.22. In the year 1977, what is the difference between the Female students (as % of total students) in Tertiary education and Female students (as % of total students) in Secondary general education?
Your response must be concise. -3.03. In the year 1977, what is the difference between the Female students (as % of total students) in Tertiary education and Female students (as % of total students) in Secondary vocational education?
Your answer should be compact. 3.32. In the year 1977, what is the difference between the Female students (as % of total students) in Secondary general education and Female students (as % of total students) in Secondary vocational education?
Keep it short and to the point. 6.35. In the year 1978, what is the difference between the Female students (as % of total students) in Primary education and Female students (as % of total students) in Tertiary education?
Give a very brief answer. 0.26. In the year 1978, what is the difference between the Female students (as % of total students) in Primary education and Female students (as % of total students) in Secondary general education?
Keep it short and to the point. -0.76. In the year 1978, what is the difference between the Female students (as % of total students) of Primary education and Female students (as % of total students) of Secondary vocational education?
Keep it short and to the point. 3.94. In the year 1978, what is the difference between the Female students (as % of total students) of Tertiary education and Female students (as % of total students) of Secondary general education?
Offer a very short reply. -1.02. In the year 1978, what is the difference between the Female students (as % of total students) in Tertiary education and Female students (as % of total students) in Secondary vocational education?
Your response must be concise. 3.68. In the year 1978, what is the difference between the Female students (as % of total students) in Secondary general education and Female students (as % of total students) in Secondary vocational education?
Offer a very short reply. 4.7. In the year 1979, what is the difference between the Female students (as % of total students) of Primary education and Female students (as % of total students) of Tertiary education?
Your answer should be compact. -0.73. In the year 1979, what is the difference between the Female students (as % of total students) in Primary education and Female students (as % of total students) in Secondary general education?
Ensure brevity in your answer.  -1.72. In the year 1979, what is the difference between the Female students (as % of total students) in Primary education and Female students (as % of total students) in Secondary vocational education?
Offer a very short reply. 2.73. In the year 1979, what is the difference between the Female students (as % of total students) in Tertiary education and Female students (as % of total students) in Secondary general education?
Provide a short and direct response. -1. In the year 1979, what is the difference between the Female students (as % of total students) of Tertiary education and Female students (as % of total students) of Secondary vocational education?
Make the answer very short. 3.46. In the year 1979, what is the difference between the Female students (as % of total students) of Secondary general education and Female students (as % of total students) of Secondary vocational education?
Offer a terse response. 4.46. In the year 1980, what is the difference between the Female students (as % of total students) in Primary education and Female students (as % of total students) in Tertiary education?
Offer a terse response. 5.86. In the year 1980, what is the difference between the Female students (as % of total students) in Primary education and Female students (as % of total students) in Secondary general education?
Ensure brevity in your answer.  -2.31. In the year 1980, what is the difference between the Female students (as % of total students) in Primary education and Female students (as % of total students) in Secondary vocational education?
Your answer should be compact. 11.42. In the year 1980, what is the difference between the Female students (as % of total students) of Tertiary education and Female students (as % of total students) of Secondary general education?
Your answer should be very brief. -8.16. In the year 1980, what is the difference between the Female students (as % of total students) of Tertiary education and Female students (as % of total students) of Secondary vocational education?
Your answer should be compact. 5.56. In the year 1980, what is the difference between the Female students (as % of total students) of Secondary general education and Female students (as % of total students) of Secondary vocational education?
Keep it short and to the point. 13.72. In the year 1981, what is the difference between the Female students (as % of total students) in Primary education and Female students (as % of total students) in Tertiary education?
Ensure brevity in your answer.  0.6. In the year 1981, what is the difference between the Female students (as % of total students) of Primary education and Female students (as % of total students) of Secondary general education?
Your answer should be compact. -5.79. In the year 1981, what is the difference between the Female students (as % of total students) in Primary education and Female students (as % of total students) in Secondary vocational education?
Your answer should be compact. 4.01. In the year 1981, what is the difference between the Female students (as % of total students) of Tertiary education and Female students (as % of total students) of Secondary general education?
Your answer should be very brief. -6.39. In the year 1981, what is the difference between the Female students (as % of total students) in Tertiary education and Female students (as % of total students) in Secondary vocational education?
Give a very brief answer. 3.41. In the year 1981, what is the difference between the Female students (as % of total students) of Secondary general education and Female students (as % of total students) of Secondary vocational education?
Offer a very short reply. 9.8. In the year 1982, what is the difference between the Female students (as % of total students) of Primary education and Female students (as % of total students) of Tertiary education?
Your answer should be very brief. 1.47. In the year 1982, what is the difference between the Female students (as % of total students) in Primary education and Female students (as % of total students) in Secondary general education?
Ensure brevity in your answer.  -6.22. In the year 1982, what is the difference between the Female students (as % of total students) of Primary education and Female students (as % of total students) of Secondary vocational education?
Offer a very short reply. 5.38. In the year 1982, what is the difference between the Female students (as % of total students) in Tertiary education and Female students (as % of total students) in Secondary general education?
Ensure brevity in your answer.  -7.68. In the year 1982, what is the difference between the Female students (as % of total students) in Tertiary education and Female students (as % of total students) in Secondary vocational education?
Provide a short and direct response. 3.92. In the year 1982, what is the difference between the Female students (as % of total students) of Secondary general education and Female students (as % of total students) of Secondary vocational education?
Give a very brief answer. 11.6. In the year 1983, what is the difference between the Female students (as % of total students) of Primary education and Female students (as % of total students) of Tertiary education?
Your response must be concise. 1.36. In the year 1983, what is the difference between the Female students (as % of total students) in Primary education and Female students (as % of total students) in Secondary general education?
Provide a short and direct response. -6.81. In the year 1983, what is the difference between the Female students (as % of total students) of Primary education and Female students (as % of total students) of Secondary vocational education?
Your answer should be very brief. 2.85. In the year 1983, what is the difference between the Female students (as % of total students) of Tertiary education and Female students (as % of total students) of Secondary general education?
Provide a succinct answer. -8.17. In the year 1983, what is the difference between the Female students (as % of total students) of Tertiary education and Female students (as % of total students) of Secondary vocational education?
Offer a very short reply. 1.49. In the year 1983, what is the difference between the Female students (as % of total students) of Secondary general education and Female students (as % of total students) of Secondary vocational education?
Make the answer very short. 9.66. In the year 1984, what is the difference between the Female students (as % of total students) of Primary education and Female students (as % of total students) of Tertiary education?
Ensure brevity in your answer.  0.12. In the year 1984, what is the difference between the Female students (as % of total students) of Primary education and Female students (as % of total students) of Secondary general education?
Your answer should be compact. -6.23. In the year 1984, what is the difference between the Female students (as % of total students) in Primary education and Female students (as % of total students) in Secondary vocational education?
Offer a very short reply. 2.67. In the year 1984, what is the difference between the Female students (as % of total students) of Tertiary education and Female students (as % of total students) of Secondary general education?
Give a very brief answer. -6.35. In the year 1984, what is the difference between the Female students (as % of total students) in Tertiary education and Female students (as % of total students) in Secondary vocational education?
Offer a terse response. 2.55. In the year 1984, what is the difference between the Female students (as % of total students) in Secondary general education and Female students (as % of total students) in Secondary vocational education?
Your response must be concise. 8.9. What is the ratio of the Female students (as % of total students) in Tertiary education in 1976 to that in 1977?
Ensure brevity in your answer.  1.01. What is the ratio of the Female students (as % of total students) of Secondary general education in 1976 to that in 1977?
Offer a very short reply. 0.97. What is the ratio of the Female students (as % of total students) in Secondary vocational education in 1976 to that in 1977?
Keep it short and to the point. 0.96. What is the ratio of the Female students (as % of total students) of Secondary vocational education in 1976 to that in 1978?
Your answer should be very brief. 0.96. What is the ratio of the Female students (as % of total students) in Secondary general education in 1976 to that in 1979?
Your answer should be very brief. 0.98. What is the ratio of the Female students (as % of total students) of Secondary vocational education in 1976 to that in 1979?
Ensure brevity in your answer.  0.94. What is the ratio of the Female students (as % of total students) in Primary education in 1976 to that in 1980?
Offer a very short reply. 1.01. What is the ratio of the Female students (as % of total students) in Tertiary education in 1976 to that in 1980?
Your answer should be very brief. 1.14. What is the ratio of the Female students (as % of total students) in Secondary general education in 1976 to that in 1980?
Offer a very short reply. 0.97. What is the ratio of the Female students (as % of total students) of Secondary vocational education in 1976 to that in 1980?
Provide a succinct answer. 1.17. What is the ratio of the Female students (as % of total students) in Primary education in 1976 to that in 1981?
Offer a terse response. 1.01. What is the ratio of the Female students (as % of total students) in Tertiary education in 1976 to that in 1981?
Provide a succinct answer. 1.02. What is the ratio of the Female students (as % of total students) of Secondary general education in 1976 to that in 1981?
Provide a short and direct response. 0.92. What is the ratio of the Female students (as % of total students) of Secondary vocational education in 1976 to that in 1981?
Keep it short and to the point. 0.98. What is the ratio of the Female students (as % of total students) in Primary education in 1976 to that in 1982?
Offer a very short reply. 1.01. What is the ratio of the Female students (as % of total students) of Secondary general education in 1976 to that in 1982?
Ensure brevity in your answer.  0.91. What is the ratio of the Female students (as % of total students) of Secondary vocational education in 1976 to that in 1982?
Provide a short and direct response. 1.01. What is the ratio of the Female students (as % of total students) of Primary education in 1976 to that in 1983?
Give a very brief answer. 1.01. What is the ratio of the Female students (as % of total students) of Tertiary education in 1976 to that in 1983?
Ensure brevity in your answer.  1.04. What is the ratio of the Female students (as % of total students) in Secondary general education in 1976 to that in 1983?
Your answer should be compact. 0.9. What is the ratio of the Female students (as % of total students) of Secondary vocational education in 1976 to that in 1983?
Keep it short and to the point. 0.96. What is the ratio of the Female students (as % of total students) in Primary education in 1976 to that in 1984?
Ensure brevity in your answer.  1.01. What is the ratio of the Female students (as % of total students) of Tertiary education in 1976 to that in 1984?
Provide a short and direct response. 1.01. What is the ratio of the Female students (as % of total students) of Secondary general education in 1976 to that in 1984?
Provide a succinct answer. 0.91. What is the ratio of the Female students (as % of total students) of Secondary vocational education in 1976 to that in 1984?
Your answer should be compact. 0.95. What is the ratio of the Female students (as % of total students) in Primary education in 1977 to that in 1978?
Give a very brief answer. 1. What is the ratio of the Female students (as % of total students) in Tertiary education in 1977 to that in 1978?
Keep it short and to the point. 0.99. What is the ratio of the Female students (as % of total students) of Secondary general education in 1977 to that in 1978?
Make the answer very short. 1.03. What is the ratio of the Female students (as % of total students) in Secondary vocational education in 1977 to that in 1978?
Your answer should be compact. 1. What is the ratio of the Female students (as % of total students) of Primary education in 1977 to that in 1979?
Ensure brevity in your answer.  1.01. What is the ratio of the Female students (as % of total students) of Tertiary education in 1977 to that in 1979?
Your response must be concise. 0.98. What is the ratio of the Female students (as % of total students) of Secondary general education in 1977 to that in 1979?
Provide a succinct answer. 1.02. What is the ratio of the Female students (as % of total students) of Secondary vocational education in 1977 to that in 1979?
Your answer should be very brief. 0.98. What is the ratio of the Female students (as % of total students) of Primary education in 1977 to that in 1980?
Give a very brief answer. 1.01. What is the ratio of the Female students (as % of total students) in Tertiary education in 1977 to that in 1980?
Your answer should be very brief. 1.13. What is the ratio of the Female students (as % of total students) in Secondary general education in 1977 to that in 1980?
Make the answer very short. 1.01. What is the ratio of the Female students (as % of total students) in Secondary vocational education in 1977 to that in 1980?
Give a very brief answer. 1.21. What is the ratio of the Female students (as % of total students) in Primary education in 1977 to that in 1981?
Offer a terse response. 1.02. What is the ratio of the Female students (as % of total students) in Tertiary education in 1977 to that in 1981?
Your answer should be compact. 1.01. What is the ratio of the Female students (as % of total students) in Secondary general education in 1977 to that in 1981?
Offer a very short reply. 0.95. What is the ratio of the Female students (as % of total students) of Secondary vocational education in 1977 to that in 1981?
Your answer should be compact. 1.02. What is the ratio of the Female students (as % of total students) in Primary education in 1977 to that in 1982?
Give a very brief answer. 1.01. What is the ratio of the Female students (as % of total students) in Tertiary education in 1977 to that in 1982?
Offer a very short reply. 1.03. What is the ratio of the Female students (as % of total students) in Secondary general education in 1977 to that in 1982?
Your response must be concise. 0.94. What is the ratio of the Female students (as % of total students) in Secondary vocational education in 1977 to that in 1982?
Keep it short and to the point. 1.04. What is the ratio of the Female students (as % of total students) in Primary education in 1977 to that in 1983?
Your response must be concise. 1.02. What is the ratio of the Female students (as % of total students) of Tertiary education in 1977 to that in 1983?
Provide a succinct answer. 1.03. What is the ratio of the Female students (as % of total students) in Secondary general education in 1977 to that in 1983?
Provide a succinct answer. 0.93. What is the ratio of the Female students (as % of total students) in Primary education in 1977 to that in 1984?
Give a very brief answer. 1.02. What is the ratio of the Female students (as % of total students) of Tertiary education in 1977 to that in 1984?
Your answer should be compact. 1. What is the ratio of the Female students (as % of total students) in Secondary general education in 1977 to that in 1984?
Make the answer very short. 0.94. What is the ratio of the Female students (as % of total students) in Secondary vocational education in 1977 to that in 1984?
Offer a terse response. 0.98. What is the ratio of the Female students (as % of total students) of Primary education in 1978 to that in 1979?
Make the answer very short. 1.01. What is the ratio of the Female students (as % of total students) in Tertiary education in 1978 to that in 1979?
Your answer should be very brief. 0.99. What is the ratio of the Female students (as % of total students) in Secondary vocational education in 1978 to that in 1979?
Offer a very short reply. 0.98. What is the ratio of the Female students (as % of total students) in Primary education in 1978 to that in 1980?
Offer a very short reply. 1.01. What is the ratio of the Female students (as % of total students) of Tertiary education in 1978 to that in 1980?
Your answer should be very brief. 1.14. What is the ratio of the Female students (as % of total students) of Secondary general education in 1978 to that in 1980?
Provide a succinct answer. 0.98. What is the ratio of the Female students (as % of total students) in Secondary vocational education in 1978 to that in 1980?
Your answer should be compact. 1.21. What is the ratio of the Female students (as % of total students) of Primary education in 1978 to that in 1981?
Provide a short and direct response. 1.02. What is the ratio of the Female students (as % of total students) of Tertiary education in 1978 to that in 1981?
Make the answer very short. 1.02. What is the ratio of the Female students (as % of total students) in Secondary general education in 1978 to that in 1981?
Offer a very short reply. 0.92. What is the ratio of the Female students (as % of total students) of Secondary vocational education in 1978 to that in 1981?
Provide a succinct answer. 1.02. What is the ratio of the Female students (as % of total students) in Primary education in 1978 to that in 1982?
Offer a terse response. 1.01. What is the ratio of the Female students (as % of total students) in Tertiary education in 1978 to that in 1982?
Offer a terse response. 1.04. What is the ratio of the Female students (as % of total students) of Secondary general education in 1978 to that in 1982?
Make the answer very short. 0.91. What is the ratio of the Female students (as % of total students) in Secondary vocational education in 1978 to that in 1982?
Ensure brevity in your answer.  1.05. What is the ratio of the Female students (as % of total students) of Primary education in 1978 to that in 1983?
Give a very brief answer. 1.02. What is the ratio of the Female students (as % of total students) in Tertiary education in 1978 to that in 1983?
Your answer should be very brief. 1.04. What is the ratio of the Female students (as % of total students) in Secondary general education in 1978 to that in 1983?
Keep it short and to the point. 0.9. What is the ratio of the Female students (as % of total students) in Secondary vocational education in 1978 to that in 1983?
Provide a short and direct response. 0.99. What is the ratio of the Female students (as % of total students) in Primary education in 1978 to that in 1984?
Your answer should be very brief. 1.01. What is the ratio of the Female students (as % of total students) of Tertiary education in 1978 to that in 1984?
Provide a short and direct response. 1.01. What is the ratio of the Female students (as % of total students) in Secondary general education in 1978 to that in 1984?
Provide a succinct answer. 0.91. What is the ratio of the Female students (as % of total students) in Secondary vocational education in 1978 to that in 1984?
Your response must be concise. 0.99. What is the ratio of the Female students (as % of total students) in Tertiary education in 1979 to that in 1980?
Ensure brevity in your answer.  1.16. What is the ratio of the Female students (as % of total students) in Secondary vocational education in 1979 to that in 1980?
Provide a short and direct response. 1.24. What is the ratio of the Female students (as % of total students) in Primary education in 1979 to that in 1981?
Offer a very short reply. 1.01. What is the ratio of the Female students (as % of total students) in Tertiary education in 1979 to that in 1981?
Your answer should be compact. 1.04. What is the ratio of the Female students (as % of total students) in Secondary general education in 1979 to that in 1981?
Make the answer very short. 0.93. What is the ratio of the Female students (as % of total students) of Secondary vocational education in 1979 to that in 1981?
Ensure brevity in your answer.  1.04. What is the ratio of the Female students (as % of total students) in Primary education in 1979 to that in 1982?
Provide a succinct answer. 1. What is the ratio of the Female students (as % of total students) in Tertiary education in 1979 to that in 1982?
Ensure brevity in your answer.  1.05. What is the ratio of the Female students (as % of total students) in Secondary general education in 1979 to that in 1982?
Provide a succinct answer. 0.92. What is the ratio of the Female students (as % of total students) in Secondary vocational education in 1979 to that in 1982?
Ensure brevity in your answer.  1.07. What is the ratio of the Female students (as % of total students) of Primary education in 1979 to that in 1983?
Ensure brevity in your answer.  1.01. What is the ratio of the Female students (as % of total students) in Tertiary education in 1979 to that in 1983?
Your answer should be very brief. 1.05. What is the ratio of the Female students (as % of total students) of Secondary general education in 1979 to that in 1983?
Provide a succinct answer. 0.92. What is the ratio of the Female students (as % of total students) in Secondary vocational education in 1979 to that in 1983?
Provide a succinct answer. 1.01. What is the ratio of the Female students (as % of total students) in Primary education in 1979 to that in 1984?
Keep it short and to the point. 1.01. What is the ratio of the Female students (as % of total students) in Tertiary education in 1979 to that in 1984?
Your answer should be very brief. 1.03. What is the ratio of the Female students (as % of total students) in Secondary general education in 1979 to that in 1984?
Offer a terse response. 0.92. What is the ratio of the Female students (as % of total students) in Secondary vocational education in 1979 to that in 1984?
Your response must be concise. 1.01. What is the ratio of the Female students (as % of total students) in Primary education in 1980 to that in 1981?
Give a very brief answer. 1.01. What is the ratio of the Female students (as % of total students) in Tertiary education in 1980 to that in 1981?
Your answer should be compact. 0.9. What is the ratio of the Female students (as % of total students) of Secondary general education in 1980 to that in 1981?
Ensure brevity in your answer.  0.94. What is the ratio of the Female students (as % of total students) in Secondary vocational education in 1980 to that in 1981?
Offer a terse response. 0.84. What is the ratio of the Female students (as % of total students) in Primary education in 1980 to that in 1982?
Provide a short and direct response. 1. What is the ratio of the Female students (as % of total students) in Tertiary education in 1980 to that in 1982?
Provide a short and direct response. 0.91. What is the ratio of the Female students (as % of total students) of Secondary general education in 1980 to that in 1982?
Keep it short and to the point. 0.93. What is the ratio of the Female students (as % of total students) of Secondary vocational education in 1980 to that in 1982?
Give a very brief answer. 0.86. What is the ratio of the Female students (as % of total students) of Primary education in 1980 to that in 1983?
Your answer should be compact. 1.01. What is the ratio of the Female students (as % of total students) of Tertiary education in 1980 to that in 1983?
Offer a very short reply. 0.91. What is the ratio of the Female students (as % of total students) of Secondary general education in 1980 to that in 1983?
Give a very brief answer. 0.92. What is the ratio of the Female students (as % of total students) in Secondary vocational education in 1980 to that in 1983?
Offer a terse response. 0.82. What is the ratio of the Female students (as % of total students) in Tertiary education in 1980 to that in 1984?
Offer a very short reply. 0.89. What is the ratio of the Female students (as % of total students) in Secondary general education in 1980 to that in 1984?
Your answer should be very brief. 0.93. What is the ratio of the Female students (as % of total students) of Secondary vocational education in 1980 to that in 1984?
Your answer should be compact. 0.81. What is the ratio of the Female students (as % of total students) of Primary education in 1981 to that in 1982?
Give a very brief answer. 1. What is the ratio of the Female students (as % of total students) of Tertiary education in 1981 to that in 1982?
Your answer should be very brief. 1.01. What is the ratio of the Female students (as % of total students) of Secondary general education in 1981 to that in 1982?
Ensure brevity in your answer.  0.99. What is the ratio of the Female students (as % of total students) of Secondary vocational education in 1981 to that in 1982?
Provide a short and direct response. 1.03. What is the ratio of the Female students (as % of total students) in Primary education in 1981 to that in 1983?
Offer a terse response. 1. What is the ratio of the Female students (as % of total students) in Tertiary education in 1981 to that in 1983?
Provide a succinct answer. 1.02. What is the ratio of the Female students (as % of total students) in Secondary general education in 1981 to that in 1983?
Offer a terse response. 0.98. What is the ratio of the Female students (as % of total students) of Secondary vocational education in 1981 to that in 1983?
Offer a very short reply. 0.98. What is the ratio of the Female students (as % of total students) in Primary education in 1981 to that in 1984?
Make the answer very short. 1. What is the ratio of the Female students (as % of total students) of Tertiary education in 1981 to that in 1984?
Offer a very short reply. 0.99. What is the ratio of the Female students (as % of total students) of Secondary general education in 1981 to that in 1984?
Give a very brief answer. 0.99. What is the ratio of the Female students (as % of total students) of Secondary vocational education in 1981 to that in 1984?
Ensure brevity in your answer.  0.97. What is the ratio of the Female students (as % of total students) in Primary education in 1982 to that in 1983?
Your answer should be very brief. 1.01. What is the ratio of the Female students (as % of total students) of Secondary vocational education in 1982 to that in 1983?
Your answer should be very brief. 0.95. What is the ratio of the Female students (as % of total students) of Tertiary education in 1982 to that in 1984?
Your answer should be very brief. 0.98. What is the ratio of the Female students (as % of total students) in Secondary general education in 1982 to that in 1984?
Give a very brief answer. 1. What is the ratio of the Female students (as % of total students) in Secondary vocational education in 1982 to that in 1984?
Give a very brief answer. 0.94. What is the ratio of the Female students (as % of total students) of Tertiary education in 1983 to that in 1984?
Your response must be concise. 0.97. What is the ratio of the Female students (as % of total students) of Secondary general education in 1983 to that in 1984?
Provide a succinct answer. 1.01. What is the difference between the highest and the second highest Female students (as % of total students) in Primary education?
Keep it short and to the point. 0.16. What is the difference between the highest and the second highest Female students (as % of total students) of Tertiary education?
Provide a short and direct response. 0.66. What is the difference between the highest and the second highest Female students (as % of total students) in Secondary general education?
Offer a terse response. 0.34. What is the difference between the highest and the second highest Female students (as % of total students) in Secondary vocational education?
Keep it short and to the point. 0.3. What is the difference between the highest and the lowest Female students (as % of total students) of Primary education?
Keep it short and to the point. 0.94. What is the difference between the highest and the lowest Female students (as % of total students) of Tertiary education?
Your answer should be compact. 6.72. What is the difference between the highest and the lowest Female students (as % of total students) of Secondary general education?
Give a very brief answer. 5.47. What is the difference between the highest and the lowest Female students (as % of total students) of Secondary vocational education?
Provide a short and direct response. 8.82. 